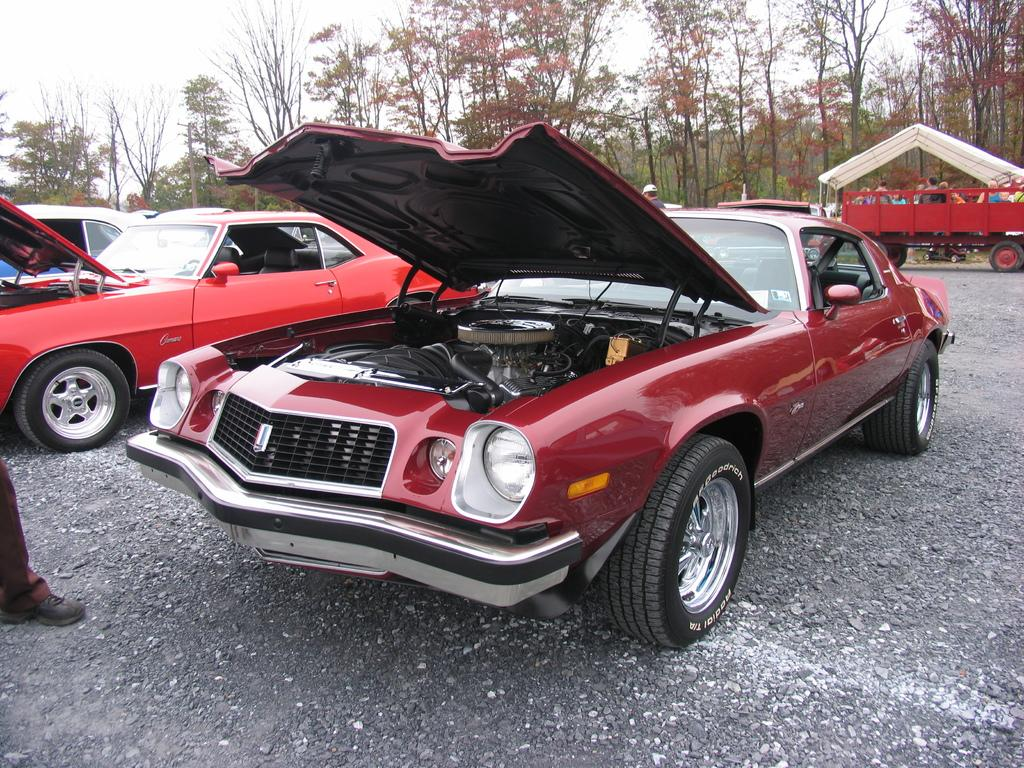What can be seen parked in the image? There are cars parked in the image. What else can be seen in the image besides the parked cars? There are people standing in the image. What can be seen in the distance in the image? There are trees visible in the background of the image. What type of magic is being performed by the people in the image? There is no indication of magic being performed in the image; it simply shows parked cars, people standing, and trees in the background. 